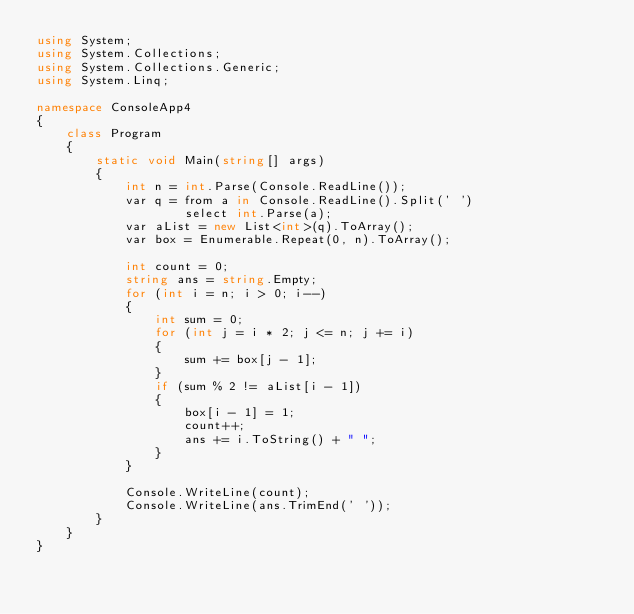<code> <loc_0><loc_0><loc_500><loc_500><_C#_>using System;
using System.Collections;
using System.Collections.Generic;
using System.Linq;

namespace ConsoleApp4
{
	class Program
	{
		static void Main(string[] args)
		{
			int n = int.Parse(Console.ReadLine());
			var q = from a in Console.ReadLine().Split(' ')
					select int.Parse(a);
			var aList = new List<int>(q).ToArray();
			var box = Enumerable.Repeat(0, n).ToArray();

			int count = 0;
			string ans = string.Empty;
			for (int i = n; i > 0; i--)
			{
				int sum = 0;
				for (int j = i * 2; j <= n; j += i)
				{
					sum += box[j - 1];
				}
				if (sum % 2 != aList[i - 1])
				{
					box[i - 1] = 1;
					count++;
					ans += i.ToString() + " ";
				}
			}

			Console.WriteLine(count);
			Console.WriteLine(ans.TrimEnd(' '));
		}
	}
}
</code> 